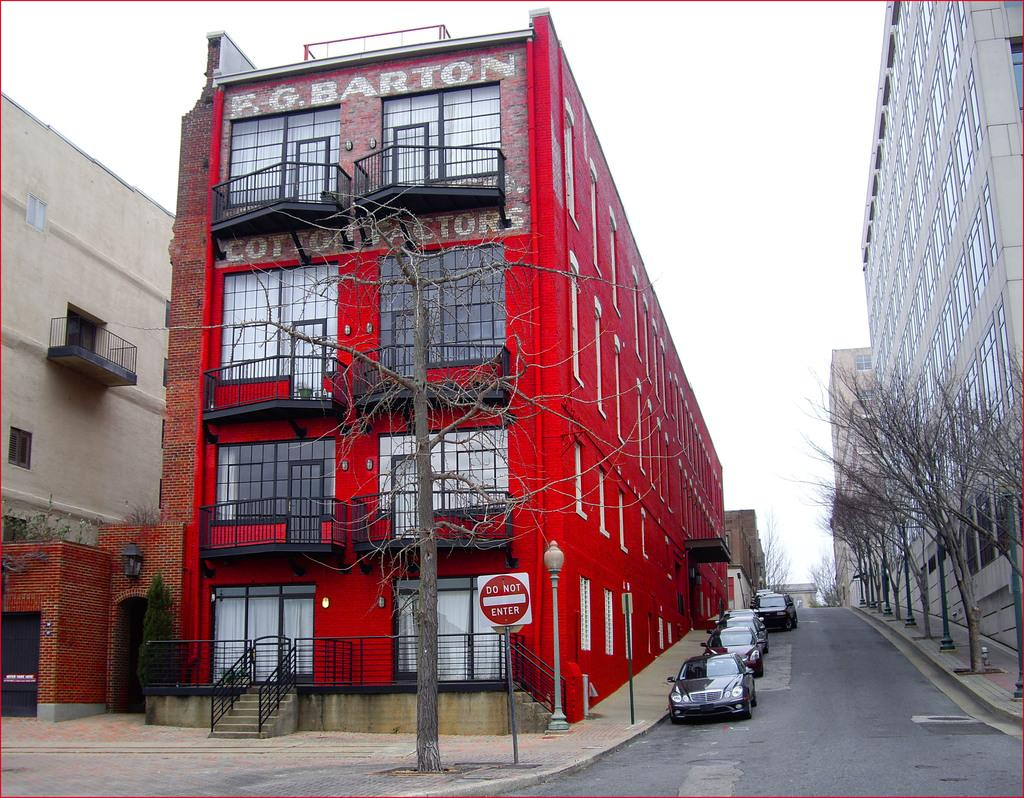What is the main subject in the center of the image? There is a building in the center of the image. What else can be seen in the image besides the building? There are cars and trees in the image. What type of suit can be seen hanging from the curtain in the image? There is no suit or curtain present in the image. What activity is taking place in the image? The image does not depict any specific activity; it shows a building, cars, and trees. 